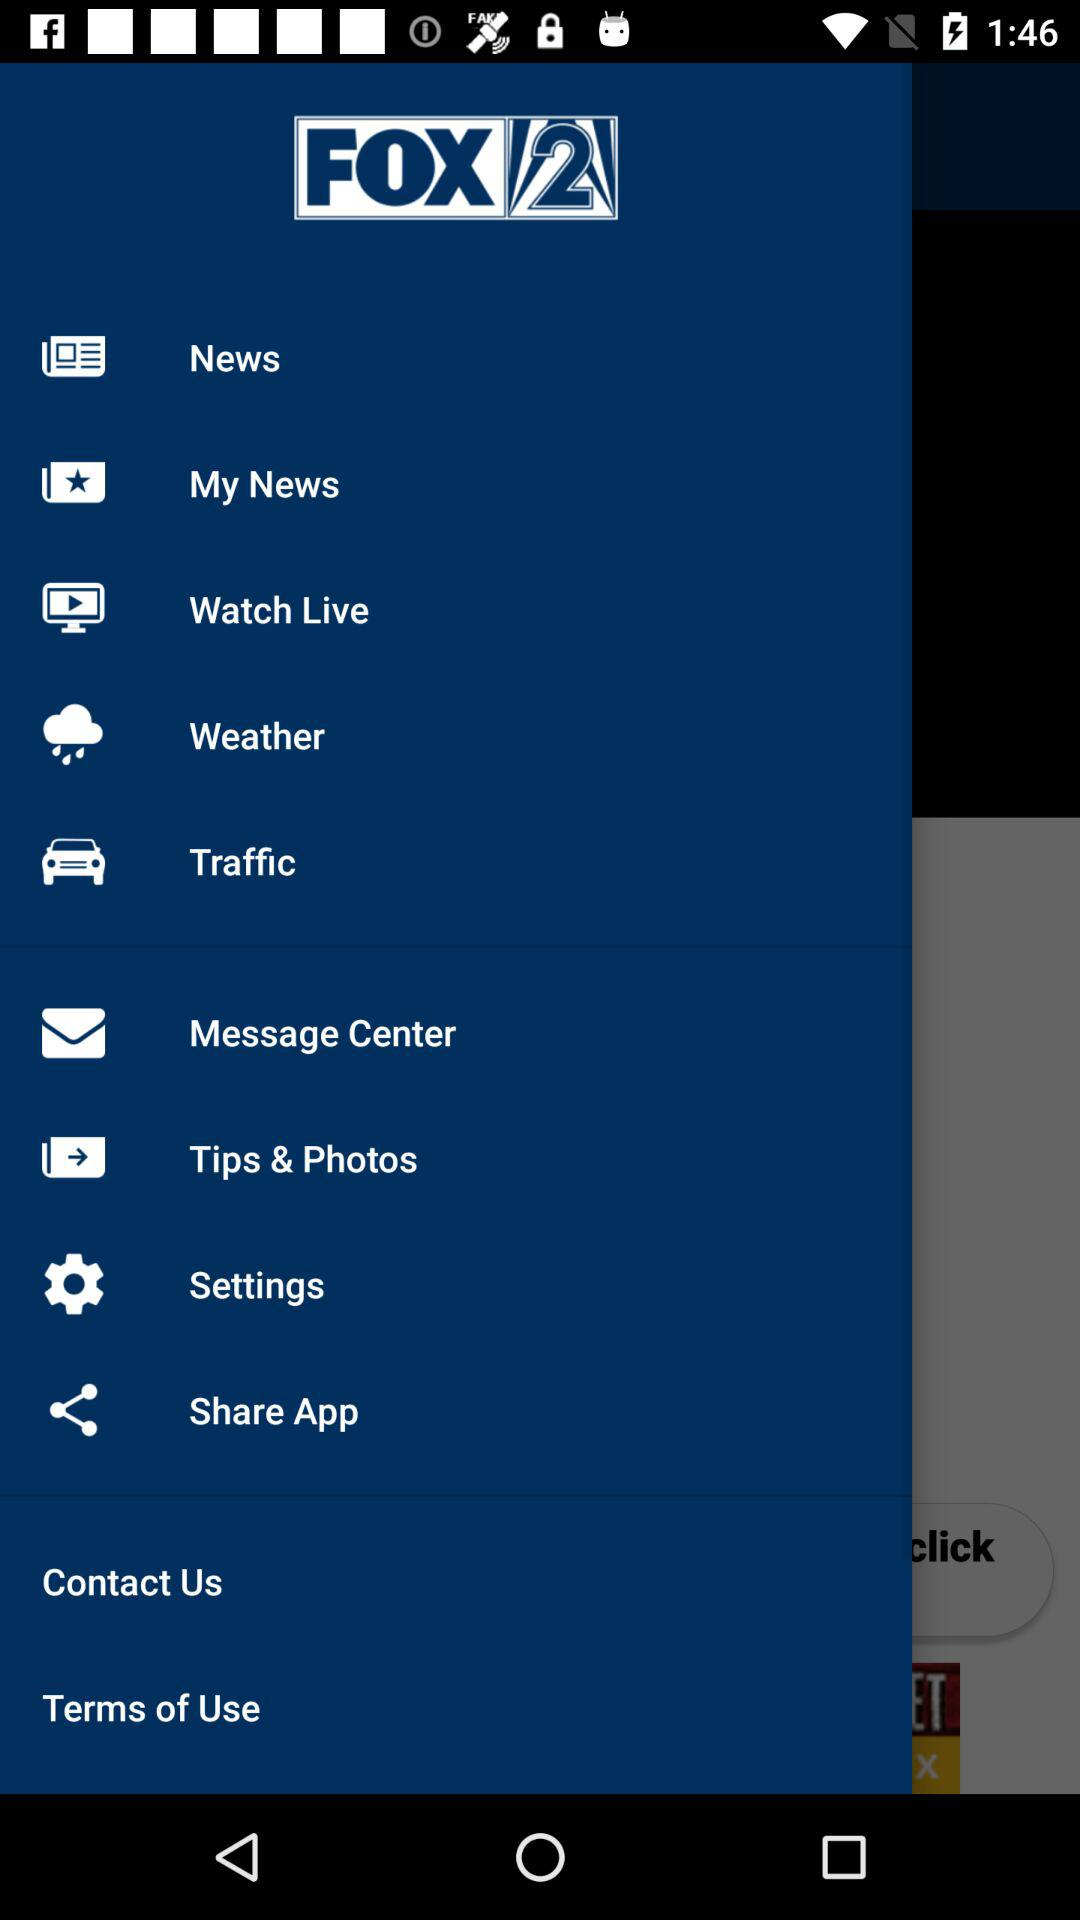Will there be thunderstorms tomorrow?
When the provided information is insufficient, respond with <no answer>. <no answer> 